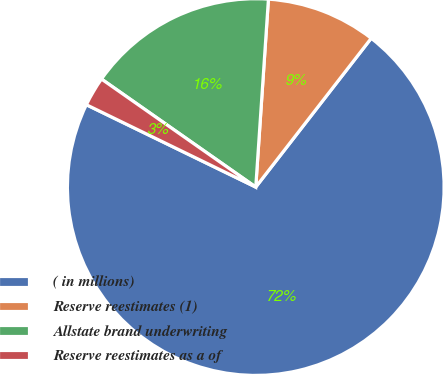Convert chart to OTSL. <chart><loc_0><loc_0><loc_500><loc_500><pie_chart><fcel>( in millions)<fcel>Reserve reestimates (1)<fcel>Allstate brand underwriting<fcel>Reserve reestimates as a of<nl><fcel>71.7%<fcel>9.43%<fcel>16.35%<fcel>2.52%<nl></chart> 